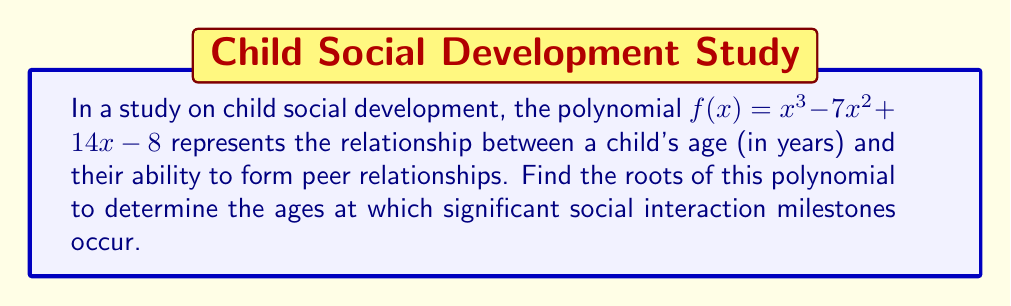Provide a solution to this math problem. To find the roots of the polynomial $f(x) = x^3 - 7x^2 + 14x - 8$, we need to factor it.

Step 1: Check for rational roots using the rational root theorem.
Possible rational roots: $\pm 1, \pm 2, \pm 4, \pm 8$

Step 2: Use synthetic division to test these roots.
Testing $x = 1$:
$$
\begin{array}{r}
1 \enclose{longdiv}{1 \quad -7 \quad 14 \quad -8} \\
\underline{1 \quad -6 \quad 8} \\
1 \quad -6 \quad 8 \quad 0
\end{array}
$$

We find that $x = 1$ is a root.

Step 3: Factor out $(x - 1)$:
$f(x) = (x - 1)(x^2 - 6x + 8)$

Step 4: Use the quadratic formula to solve $x^2 - 6x + 8 = 0$:
$x = \frac{-b \pm \sqrt{b^2 - 4ac}}{2a}$

$x = \frac{6 \pm \sqrt{36 - 32}}{2} = \frac{6 \pm 2}{2}$

$x = 4$ or $x = 2$

Therefore, the roots of the polynomial are 1, 2, and 4.

In the context of child development, these roots represent ages (in years) at which significant social interaction milestones occur:
1 year: Early social awareness
2 years: Basic peer interaction
4 years: Complex social play and friendship formation
Answer: $x = 1, 2, 4$ 